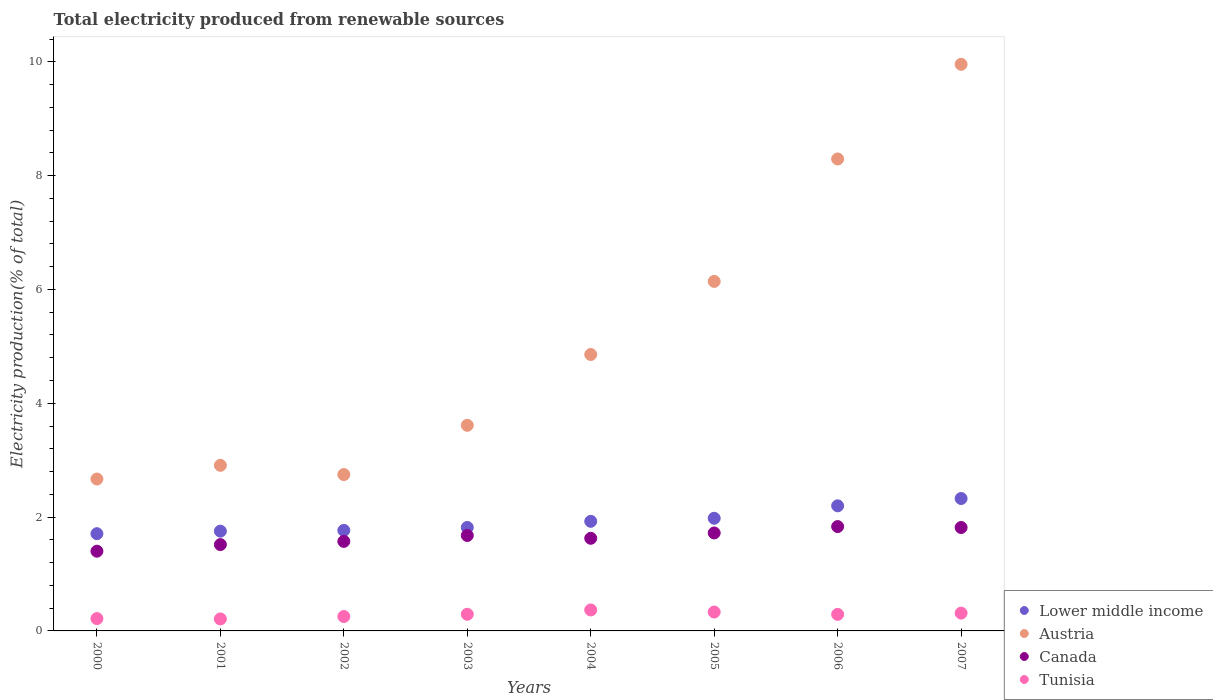How many different coloured dotlines are there?
Your response must be concise. 4. Is the number of dotlines equal to the number of legend labels?
Make the answer very short. Yes. What is the total electricity produced in Lower middle income in 2001?
Offer a terse response. 1.75. Across all years, what is the maximum total electricity produced in Austria?
Keep it short and to the point. 9.96. Across all years, what is the minimum total electricity produced in Canada?
Your answer should be very brief. 1.4. In which year was the total electricity produced in Canada maximum?
Provide a succinct answer. 2006. What is the total total electricity produced in Lower middle income in the graph?
Ensure brevity in your answer.  15.48. What is the difference between the total electricity produced in Lower middle income in 2001 and that in 2007?
Provide a succinct answer. -0.57. What is the difference between the total electricity produced in Tunisia in 2006 and the total electricity produced in Canada in 2001?
Provide a short and direct response. -1.23. What is the average total electricity produced in Austria per year?
Give a very brief answer. 5.15. In the year 2005, what is the difference between the total electricity produced in Austria and total electricity produced in Tunisia?
Keep it short and to the point. 5.81. In how many years, is the total electricity produced in Canada greater than 2 %?
Offer a terse response. 0. What is the ratio of the total electricity produced in Lower middle income in 2004 to that in 2007?
Make the answer very short. 0.83. Is the total electricity produced in Canada in 2001 less than that in 2006?
Keep it short and to the point. Yes. Is the difference between the total electricity produced in Austria in 2001 and 2002 greater than the difference between the total electricity produced in Tunisia in 2001 and 2002?
Your response must be concise. Yes. What is the difference between the highest and the second highest total electricity produced in Lower middle income?
Give a very brief answer. 0.13. What is the difference between the highest and the lowest total electricity produced in Austria?
Offer a very short reply. 7.29. Is the sum of the total electricity produced in Tunisia in 2004 and 2006 greater than the maximum total electricity produced in Lower middle income across all years?
Give a very brief answer. No. Is it the case that in every year, the sum of the total electricity produced in Tunisia and total electricity produced in Canada  is greater than the total electricity produced in Lower middle income?
Keep it short and to the point. No. Is the total electricity produced in Lower middle income strictly greater than the total electricity produced in Canada over the years?
Make the answer very short. Yes. Is the total electricity produced in Tunisia strictly less than the total electricity produced in Lower middle income over the years?
Offer a very short reply. Yes. How many dotlines are there?
Offer a very short reply. 4. What is the difference between two consecutive major ticks on the Y-axis?
Give a very brief answer. 2. Does the graph contain any zero values?
Keep it short and to the point. No. Where does the legend appear in the graph?
Make the answer very short. Bottom right. How many legend labels are there?
Provide a short and direct response. 4. How are the legend labels stacked?
Offer a terse response. Vertical. What is the title of the graph?
Keep it short and to the point. Total electricity produced from renewable sources. Does "Costa Rica" appear as one of the legend labels in the graph?
Your answer should be very brief. No. What is the Electricity production(% of total) of Lower middle income in 2000?
Ensure brevity in your answer.  1.71. What is the Electricity production(% of total) in Austria in 2000?
Provide a succinct answer. 2.67. What is the Electricity production(% of total) in Canada in 2000?
Keep it short and to the point. 1.4. What is the Electricity production(% of total) of Tunisia in 2000?
Offer a very short reply. 0.22. What is the Electricity production(% of total) of Lower middle income in 2001?
Provide a short and direct response. 1.75. What is the Electricity production(% of total) of Austria in 2001?
Offer a terse response. 2.91. What is the Electricity production(% of total) of Canada in 2001?
Make the answer very short. 1.52. What is the Electricity production(% of total) of Tunisia in 2001?
Your response must be concise. 0.21. What is the Electricity production(% of total) in Lower middle income in 2002?
Ensure brevity in your answer.  1.77. What is the Electricity production(% of total) in Austria in 2002?
Offer a very short reply. 2.75. What is the Electricity production(% of total) of Canada in 2002?
Give a very brief answer. 1.57. What is the Electricity production(% of total) of Tunisia in 2002?
Give a very brief answer. 0.25. What is the Electricity production(% of total) in Lower middle income in 2003?
Offer a very short reply. 1.82. What is the Electricity production(% of total) of Austria in 2003?
Your answer should be very brief. 3.61. What is the Electricity production(% of total) in Canada in 2003?
Give a very brief answer. 1.68. What is the Electricity production(% of total) in Tunisia in 2003?
Your response must be concise. 0.29. What is the Electricity production(% of total) in Lower middle income in 2004?
Your response must be concise. 1.93. What is the Electricity production(% of total) in Austria in 2004?
Give a very brief answer. 4.86. What is the Electricity production(% of total) of Canada in 2004?
Ensure brevity in your answer.  1.63. What is the Electricity production(% of total) of Tunisia in 2004?
Ensure brevity in your answer.  0.37. What is the Electricity production(% of total) in Lower middle income in 2005?
Offer a terse response. 1.98. What is the Electricity production(% of total) in Austria in 2005?
Make the answer very short. 6.14. What is the Electricity production(% of total) of Canada in 2005?
Your answer should be compact. 1.72. What is the Electricity production(% of total) of Tunisia in 2005?
Ensure brevity in your answer.  0.33. What is the Electricity production(% of total) in Lower middle income in 2006?
Offer a very short reply. 2.2. What is the Electricity production(% of total) of Austria in 2006?
Ensure brevity in your answer.  8.29. What is the Electricity production(% of total) of Canada in 2006?
Your answer should be compact. 1.83. What is the Electricity production(% of total) of Tunisia in 2006?
Your answer should be compact. 0.29. What is the Electricity production(% of total) of Lower middle income in 2007?
Your response must be concise. 2.33. What is the Electricity production(% of total) in Austria in 2007?
Offer a terse response. 9.96. What is the Electricity production(% of total) of Canada in 2007?
Your answer should be very brief. 1.82. What is the Electricity production(% of total) in Tunisia in 2007?
Give a very brief answer. 0.31. Across all years, what is the maximum Electricity production(% of total) of Lower middle income?
Make the answer very short. 2.33. Across all years, what is the maximum Electricity production(% of total) in Austria?
Provide a short and direct response. 9.96. Across all years, what is the maximum Electricity production(% of total) in Canada?
Ensure brevity in your answer.  1.83. Across all years, what is the maximum Electricity production(% of total) in Tunisia?
Offer a terse response. 0.37. Across all years, what is the minimum Electricity production(% of total) in Lower middle income?
Offer a very short reply. 1.71. Across all years, what is the minimum Electricity production(% of total) of Austria?
Your answer should be very brief. 2.67. Across all years, what is the minimum Electricity production(% of total) of Canada?
Give a very brief answer. 1.4. Across all years, what is the minimum Electricity production(% of total) of Tunisia?
Your answer should be very brief. 0.21. What is the total Electricity production(% of total) of Lower middle income in the graph?
Provide a succinct answer. 15.48. What is the total Electricity production(% of total) in Austria in the graph?
Give a very brief answer. 41.19. What is the total Electricity production(% of total) in Canada in the graph?
Your response must be concise. 13.17. What is the total Electricity production(% of total) of Tunisia in the graph?
Give a very brief answer. 2.28. What is the difference between the Electricity production(% of total) in Lower middle income in 2000 and that in 2001?
Your answer should be very brief. -0.04. What is the difference between the Electricity production(% of total) of Austria in 2000 and that in 2001?
Give a very brief answer. -0.24. What is the difference between the Electricity production(% of total) in Canada in 2000 and that in 2001?
Offer a terse response. -0.12. What is the difference between the Electricity production(% of total) in Tunisia in 2000 and that in 2001?
Your answer should be compact. 0.01. What is the difference between the Electricity production(% of total) in Lower middle income in 2000 and that in 2002?
Your answer should be compact. -0.06. What is the difference between the Electricity production(% of total) of Austria in 2000 and that in 2002?
Offer a terse response. -0.08. What is the difference between the Electricity production(% of total) of Canada in 2000 and that in 2002?
Provide a short and direct response. -0.17. What is the difference between the Electricity production(% of total) of Tunisia in 2000 and that in 2002?
Make the answer very short. -0.04. What is the difference between the Electricity production(% of total) in Lower middle income in 2000 and that in 2003?
Ensure brevity in your answer.  -0.11. What is the difference between the Electricity production(% of total) in Austria in 2000 and that in 2003?
Give a very brief answer. -0.94. What is the difference between the Electricity production(% of total) in Canada in 2000 and that in 2003?
Your answer should be compact. -0.28. What is the difference between the Electricity production(% of total) in Tunisia in 2000 and that in 2003?
Your answer should be very brief. -0.08. What is the difference between the Electricity production(% of total) in Lower middle income in 2000 and that in 2004?
Ensure brevity in your answer.  -0.22. What is the difference between the Electricity production(% of total) of Austria in 2000 and that in 2004?
Your response must be concise. -2.19. What is the difference between the Electricity production(% of total) of Canada in 2000 and that in 2004?
Provide a succinct answer. -0.23. What is the difference between the Electricity production(% of total) of Tunisia in 2000 and that in 2004?
Make the answer very short. -0.15. What is the difference between the Electricity production(% of total) of Lower middle income in 2000 and that in 2005?
Your answer should be very brief. -0.27. What is the difference between the Electricity production(% of total) in Austria in 2000 and that in 2005?
Offer a very short reply. -3.47. What is the difference between the Electricity production(% of total) in Canada in 2000 and that in 2005?
Offer a very short reply. -0.32. What is the difference between the Electricity production(% of total) in Tunisia in 2000 and that in 2005?
Offer a terse response. -0.11. What is the difference between the Electricity production(% of total) in Lower middle income in 2000 and that in 2006?
Provide a succinct answer. -0.49. What is the difference between the Electricity production(% of total) of Austria in 2000 and that in 2006?
Give a very brief answer. -5.62. What is the difference between the Electricity production(% of total) of Canada in 2000 and that in 2006?
Give a very brief answer. -0.43. What is the difference between the Electricity production(% of total) of Tunisia in 2000 and that in 2006?
Offer a very short reply. -0.07. What is the difference between the Electricity production(% of total) in Lower middle income in 2000 and that in 2007?
Give a very brief answer. -0.62. What is the difference between the Electricity production(% of total) in Austria in 2000 and that in 2007?
Your response must be concise. -7.29. What is the difference between the Electricity production(% of total) in Canada in 2000 and that in 2007?
Provide a succinct answer. -0.42. What is the difference between the Electricity production(% of total) of Tunisia in 2000 and that in 2007?
Provide a short and direct response. -0.1. What is the difference between the Electricity production(% of total) of Lower middle income in 2001 and that in 2002?
Your answer should be very brief. -0.01. What is the difference between the Electricity production(% of total) in Austria in 2001 and that in 2002?
Offer a very short reply. 0.16. What is the difference between the Electricity production(% of total) of Canada in 2001 and that in 2002?
Provide a short and direct response. -0.06. What is the difference between the Electricity production(% of total) in Tunisia in 2001 and that in 2002?
Provide a succinct answer. -0.04. What is the difference between the Electricity production(% of total) of Lower middle income in 2001 and that in 2003?
Your response must be concise. -0.07. What is the difference between the Electricity production(% of total) of Austria in 2001 and that in 2003?
Your answer should be compact. -0.7. What is the difference between the Electricity production(% of total) in Canada in 2001 and that in 2003?
Make the answer very short. -0.16. What is the difference between the Electricity production(% of total) of Tunisia in 2001 and that in 2003?
Give a very brief answer. -0.08. What is the difference between the Electricity production(% of total) of Lower middle income in 2001 and that in 2004?
Give a very brief answer. -0.17. What is the difference between the Electricity production(% of total) of Austria in 2001 and that in 2004?
Your response must be concise. -1.95. What is the difference between the Electricity production(% of total) in Canada in 2001 and that in 2004?
Give a very brief answer. -0.11. What is the difference between the Electricity production(% of total) of Tunisia in 2001 and that in 2004?
Offer a terse response. -0.16. What is the difference between the Electricity production(% of total) of Lower middle income in 2001 and that in 2005?
Offer a terse response. -0.23. What is the difference between the Electricity production(% of total) of Austria in 2001 and that in 2005?
Give a very brief answer. -3.23. What is the difference between the Electricity production(% of total) in Canada in 2001 and that in 2005?
Keep it short and to the point. -0.2. What is the difference between the Electricity production(% of total) of Tunisia in 2001 and that in 2005?
Provide a succinct answer. -0.12. What is the difference between the Electricity production(% of total) of Lower middle income in 2001 and that in 2006?
Offer a very short reply. -0.45. What is the difference between the Electricity production(% of total) in Austria in 2001 and that in 2006?
Your answer should be very brief. -5.38. What is the difference between the Electricity production(% of total) in Canada in 2001 and that in 2006?
Keep it short and to the point. -0.32. What is the difference between the Electricity production(% of total) of Tunisia in 2001 and that in 2006?
Provide a short and direct response. -0.08. What is the difference between the Electricity production(% of total) in Lower middle income in 2001 and that in 2007?
Make the answer very short. -0.57. What is the difference between the Electricity production(% of total) of Austria in 2001 and that in 2007?
Offer a very short reply. -7.05. What is the difference between the Electricity production(% of total) in Canada in 2001 and that in 2007?
Your answer should be compact. -0.3. What is the difference between the Electricity production(% of total) of Tunisia in 2001 and that in 2007?
Give a very brief answer. -0.1. What is the difference between the Electricity production(% of total) of Lower middle income in 2002 and that in 2003?
Your answer should be compact. -0.05. What is the difference between the Electricity production(% of total) of Austria in 2002 and that in 2003?
Give a very brief answer. -0.87. What is the difference between the Electricity production(% of total) in Canada in 2002 and that in 2003?
Make the answer very short. -0.1. What is the difference between the Electricity production(% of total) in Tunisia in 2002 and that in 2003?
Ensure brevity in your answer.  -0.04. What is the difference between the Electricity production(% of total) of Lower middle income in 2002 and that in 2004?
Make the answer very short. -0.16. What is the difference between the Electricity production(% of total) of Austria in 2002 and that in 2004?
Offer a terse response. -2.11. What is the difference between the Electricity production(% of total) of Canada in 2002 and that in 2004?
Provide a succinct answer. -0.05. What is the difference between the Electricity production(% of total) in Tunisia in 2002 and that in 2004?
Ensure brevity in your answer.  -0.12. What is the difference between the Electricity production(% of total) in Lower middle income in 2002 and that in 2005?
Provide a short and direct response. -0.21. What is the difference between the Electricity production(% of total) in Austria in 2002 and that in 2005?
Keep it short and to the point. -3.39. What is the difference between the Electricity production(% of total) of Canada in 2002 and that in 2005?
Give a very brief answer. -0.15. What is the difference between the Electricity production(% of total) of Tunisia in 2002 and that in 2005?
Ensure brevity in your answer.  -0.08. What is the difference between the Electricity production(% of total) of Lower middle income in 2002 and that in 2006?
Your answer should be compact. -0.43. What is the difference between the Electricity production(% of total) in Austria in 2002 and that in 2006?
Offer a terse response. -5.55. What is the difference between the Electricity production(% of total) of Canada in 2002 and that in 2006?
Make the answer very short. -0.26. What is the difference between the Electricity production(% of total) of Tunisia in 2002 and that in 2006?
Provide a short and direct response. -0.04. What is the difference between the Electricity production(% of total) in Lower middle income in 2002 and that in 2007?
Your response must be concise. -0.56. What is the difference between the Electricity production(% of total) of Austria in 2002 and that in 2007?
Your answer should be compact. -7.21. What is the difference between the Electricity production(% of total) of Canada in 2002 and that in 2007?
Keep it short and to the point. -0.24. What is the difference between the Electricity production(% of total) in Tunisia in 2002 and that in 2007?
Keep it short and to the point. -0.06. What is the difference between the Electricity production(% of total) of Lower middle income in 2003 and that in 2004?
Provide a short and direct response. -0.11. What is the difference between the Electricity production(% of total) in Austria in 2003 and that in 2004?
Your answer should be compact. -1.24. What is the difference between the Electricity production(% of total) in Canada in 2003 and that in 2004?
Provide a short and direct response. 0.05. What is the difference between the Electricity production(% of total) in Tunisia in 2003 and that in 2004?
Make the answer very short. -0.08. What is the difference between the Electricity production(% of total) in Lower middle income in 2003 and that in 2005?
Make the answer very short. -0.16. What is the difference between the Electricity production(% of total) of Austria in 2003 and that in 2005?
Make the answer very short. -2.53. What is the difference between the Electricity production(% of total) of Canada in 2003 and that in 2005?
Provide a succinct answer. -0.04. What is the difference between the Electricity production(% of total) in Tunisia in 2003 and that in 2005?
Your answer should be very brief. -0.04. What is the difference between the Electricity production(% of total) in Lower middle income in 2003 and that in 2006?
Provide a succinct answer. -0.38. What is the difference between the Electricity production(% of total) of Austria in 2003 and that in 2006?
Ensure brevity in your answer.  -4.68. What is the difference between the Electricity production(% of total) in Canada in 2003 and that in 2006?
Provide a short and direct response. -0.16. What is the difference between the Electricity production(% of total) in Tunisia in 2003 and that in 2006?
Provide a succinct answer. 0. What is the difference between the Electricity production(% of total) of Lower middle income in 2003 and that in 2007?
Provide a succinct answer. -0.51. What is the difference between the Electricity production(% of total) in Austria in 2003 and that in 2007?
Provide a succinct answer. -6.34. What is the difference between the Electricity production(% of total) of Canada in 2003 and that in 2007?
Make the answer very short. -0.14. What is the difference between the Electricity production(% of total) of Tunisia in 2003 and that in 2007?
Make the answer very short. -0.02. What is the difference between the Electricity production(% of total) in Lower middle income in 2004 and that in 2005?
Ensure brevity in your answer.  -0.05. What is the difference between the Electricity production(% of total) in Austria in 2004 and that in 2005?
Give a very brief answer. -1.28. What is the difference between the Electricity production(% of total) of Canada in 2004 and that in 2005?
Give a very brief answer. -0.09. What is the difference between the Electricity production(% of total) in Tunisia in 2004 and that in 2005?
Provide a succinct answer. 0.04. What is the difference between the Electricity production(% of total) in Lower middle income in 2004 and that in 2006?
Ensure brevity in your answer.  -0.27. What is the difference between the Electricity production(% of total) in Austria in 2004 and that in 2006?
Your response must be concise. -3.44. What is the difference between the Electricity production(% of total) of Canada in 2004 and that in 2006?
Provide a short and direct response. -0.21. What is the difference between the Electricity production(% of total) of Tunisia in 2004 and that in 2006?
Give a very brief answer. 0.08. What is the difference between the Electricity production(% of total) of Lower middle income in 2004 and that in 2007?
Provide a succinct answer. -0.4. What is the difference between the Electricity production(% of total) of Austria in 2004 and that in 2007?
Make the answer very short. -5.1. What is the difference between the Electricity production(% of total) of Canada in 2004 and that in 2007?
Your response must be concise. -0.19. What is the difference between the Electricity production(% of total) in Tunisia in 2004 and that in 2007?
Provide a succinct answer. 0.06. What is the difference between the Electricity production(% of total) of Lower middle income in 2005 and that in 2006?
Keep it short and to the point. -0.22. What is the difference between the Electricity production(% of total) in Austria in 2005 and that in 2006?
Give a very brief answer. -2.15. What is the difference between the Electricity production(% of total) in Canada in 2005 and that in 2006?
Give a very brief answer. -0.11. What is the difference between the Electricity production(% of total) in Tunisia in 2005 and that in 2006?
Your response must be concise. 0.04. What is the difference between the Electricity production(% of total) of Lower middle income in 2005 and that in 2007?
Make the answer very short. -0.35. What is the difference between the Electricity production(% of total) in Austria in 2005 and that in 2007?
Keep it short and to the point. -3.81. What is the difference between the Electricity production(% of total) of Canada in 2005 and that in 2007?
Make the answer very short. -0.1. What is the difference between the Electricity production(% of total) in Tunisia in 2005 and that in 2007?
Keep it short and to the point. 0.02. What is the difference between the Electricity production(% of total) in Lower middle income in 2006 and that in 2007?
Offer a very short reply. -0.13. What is the difference between the Electricity production(% of total) in Austria in 2006 and that in 2007?
Keep it short and to the point. -1.66. What is the difference between the Electricity production(% of total) of Canada in 2006 and that in 2007?
Offer a very short reply. 0.02. What is the difference between the Electricity production(% of total) in Tunisia in 2006 and that in 2007?
Your answer should be compact. -0.02. What is the difference between the Electricity production(% of total) of Lower middle income in 2000 and the Electricity production(% of total) of Austria in 2001?
Your answer should be very brief. -1.2. What is the difference between the Electricity production(% of total) of Lower middle income in 2000 and the Electricity production(% of total) of Canada in 2001?
Provide a succinct answer. 0.19. What is the difference between the Electricity production(% of total) of Lower middle income in 2000 and the Electricity production(% of total) of Tunisia in 2001?
Make the answer very short. 1.5. What is the difference between the Electricity production(% of total) in Austria in 2000 and the Electricity production(% of total) in Canada in 2001?
Make the answer very short. 1.15. What is the difference between the Electricity production(% of total) of Austria in 2000 and the Electricity production(% of total) of Tunisia in 2001?
Provide a succinct answer. 2.46. What is the difference between the Electricity production(% of total) of Canada in 2000 and the Electricity production(% of total) of Tunisia in 2001?
Offer a terse response. 1.19. What is the difference between the Electricity production(% of total) in Lower middle income in 2000 and the Electricity production(% of total) in Austria in 2002?
Your response must be concise. -1.04. What is the difference between the Electricity production(% of total) in Lower middle income in 2000 and the Electricity production(% of total) in Canada in 2002?
Your answer should be compact. 0.14. What is the difference between the Electricity production(% of total) in Lower middle income in 2000 and the Electricity production(% of total) in Tunisia in 2002?
Make the answer very short. 1.46. What is the difference between the Electricity production(% of total) of Austria in 2000 and the Electricity production(% of total) of Canada in 2002?
Provide a short and direct response. 1.1. What is the difference between the Electricity production(% of total) of Austria in 2000 and the Electricity production(% of total) of Tunisia in 2002?
Your answer should be compact. 2.42. What is the difference between the Electricity production(% of total) of Canada in 2000 and the Electricity production(% of total) of Tunisia in 2002?
Your answer should be compact. 1.15. What is the difference between the Electricity production(% of total) of Lower middle income in 2000 and the Electricity production(% of total) of Austria in 2003?
Your answer should be very brief. -1.9. What is the difference between the Electricity production(% of total) of Lower middle income in 2000 and the Electricity production(% of total) of Canada in 2003?
Offer a very short reply. 0.03. What is the difference between the Electricity production(% of total) of Lower middle income in 2000 and the Electricity production(% of total) of Tunisia in 2003?
Ensure brevity in your answer.  1.42. What is the difference between the Electricity production(% of total) in Austria in 2000 and the Electricity production(% of total) in Canada in 2003?
Ensure brevity in your answer.  0.99. What is the difference between the Electricity production(% of total) of Austria in 2000 and the Electricity production(% of total) of Tunisia in 2003?
Your response must be concise. 2.38. What is the difference between the Electricity production(% of total) of Canada in 2000 and the Electricity production(% of total) of Tunisia in 2003?
Offer a very short reply. 1.11. What is the difference between the Electricity production(% of total) in Lower middle income in 2000 and the Electricity production(% of total) in Austria in 2004?
Keep it short and to the point. -3.15. What is the difference between the Electricity production(% of total) of Lower middle income in 2000 and the Electricity production(% of total) of Canada in 2004?
Your answer should be compact. 0.08. What is the difference between the Electricity production(% of total) of Lower middle income in 2000 and the Electricity production(% of total) of Tunisia in 2004?
Your response must be concise. 1.34. What is the difference between the Electricity production(% of total) in Austria in 2000 and the Electricity production(% of total) in Canada in 2004?
Ensure brevity in your answer.  1.04. What is the difference between the Electricity production(% of total) of Austria in 2000 and the Electricity production(% of total) of Tunisia in 2004?
Give a very brief answer. 2.3. What is the difference between the Electricity production(% of total) in Canada in 2000 and the Electricity production(% of total) in Tunisia in 2004?
Your response must be concise. 1.03. What is the difference between the Electricity production(% of total) of Lower middle income in 2000 and the Electricity production(% of total) of Austria in 2005?
Make the answer very short. -4.43. What is the difference between the Electricity production(% of total) in Lower middle income in 2000 and the Electricity production(% of total) in Canada in 2005?
Offer a terse response. -0.01. What is the difference between the Electricity production(% of total) in Lower middle income in 2000 and the Electricity production(% of total) in Tunisia in 2005?
Ensure brevity in your answer.  1.38. What is the difference between the Electricity production(% of total) in Austria in 2000 and the Electricity production(% of total) in Canada in 2005?
Make the answer very short. 0.95. What is the difference between the Electricity production(% of total) in Austria in 2000 and the Electricity production(% of total) in Tunisia in 2005?
Provide a succinct answer. 2.34. What is the difference between the Electricity production(% of total) in Canada in 2000 and the Electricity production(% of total) in Tunisia in 2005?
Make the answer very short. 1.07. What is the difference between the Electricity production(% of total) of Lower middle income in 2000 and the Electricity production(% of total) of Austria in 2006?
Your answer should be compact. -6.58. What is the difference between the Electricity production(% of total) in Lower middle income in 2000 and the Electricity production(% of total) in Canada in 2006?
Provide a short and direct response. -0.13. What is the difference between the Electricity production(% of total) in Lower middle income in 2000 and the Electricity production(% of total) in Tunisia in 2006?
Offer a terse response. 1.42. What is the difference between the Electricity production(% of total) of Austria in 2000 and the Electricity production(% of total) of Canada in 2006?
Your answer should be very brief. 0.84. What is the difference between the Electricity production(% of total) in Austria in 2000 and the Electricity production(% of total) in Tunisia in 2006?
Ensure brevity in your answer.  2.38. What is the difference between the Electricity production(% of total) in Canada in 2000 and the Electricity production(% of total) in Tunisia in 2006?
Your answer should be very brief. 1.11. What is the difference between the Electricity production(% of total) in Lower middle income in 2000 and the Electricity production(% of total) in Austria in 2007?
Keep it short and to the point. -8.25. What is the difference between the Electricity production(% of total) in Lower middle income in 2000 and the Electricity production(% of total) in Canada in 2007?
Give a very brief answer. -0.11. What is the difference between the Electricity production(% of total) in Lower middle income in 2000 and the Electricity production(% of total) in Tunisia in 2007?
Give a very brief answer. 1.4. What is the difference between the Electricity production(% of total) in Austria in 2000 and the Electricity production(% of total) in Canada in 2007?
Offer a very short reply. 0.85. What is the difference between the Electricity production(% of total) in Austria in 2000 and the Electricity production(% of total) in Tunisia in 2007?
Keep it short and to the point. 2.36. What is the difference between the Electricity production(% of total) in Canada in 2000 and the Electricity production(% of total) in Tunisia in 2007?
Provide a short and direct response. 1.09. What is the difference between the Electricity production(% of total) of Lower middle income in 2001 and the Electricity production(% of total) of Austria in 2002?
Provide a succinct answer. -0.99. What is the difference between the Electricity production(% of total) in Lower middle income in 2001 and the Electricity production(% of total) in Canada in 2002?
Ensure brevity in your answer.  0.18. What is the difference between the Electricity production(% of total) of Lower middle income in 2001 and the Electricity production(% of total) of Tunisia in 2002?
Your answer should be very brief. 1.5. What is the difference between the Electricity production(% of total) in Austria in 2001 and the Electricity production(% of total) in Canada in 2002?
Your answer should be compact. 1.34. What is the difference between the Electricity production(% of total) in Austria in 2001 and the Electricity production(% of total) in Tunisia in 2002?
Keep it short and to the point. 2.66. What is the difference between the Electricity production(% of total) of Canada in 2001 and the Electricity production(% of total) of Tunisia in 2002?
Provide a succinct answer. 1.26. What is the difference between the Electricity production(% of total) in Lower middle income in 2001 and the Electricity production(% of total) in Austria in 2003?
Your response must be concise. -1.86. What is the difference between the Electricity production(% of total) in Lower middle income in 2001 and the Electricity production(% of total) in Canada in 2003?
Provide a short and direct response. 0.08. What is the difference between the Electricity production(% of total) of Lower middle income in 2001 and the Electricity production(% of total) of Tunisia in 2003?
Provide a short and direct response. 1.46. What is the difference between the Electricity production(% of total) of Austria in 2001 and the Electricity production(% of total) of Canada in 2003?
Provide a succinct answer. 1.23. What is the difference between the Electricity production(% of total) of Austria in 2001 and the Electricity production(% of total) of Tunisia in 2003?
Keep it short and to the point. 2.62. What is the difference between the Electricity production(% of total) of Canada in 2001 and the Electricity production(% of total) of Tunisia in 2003?
Provide a succinct answer. 1.22. What is the difference between the Electricity production(% of total) in Lower middle income in 2001 and the Electricity production(% of total) in Austria in 2004?
Offer a terse response. -3.1. What is the difference between the Electricity production(% of total) of Lower middle income in 2001 and the Electricity production(% of total) of Canada in 2004?
Make the answer very short. 0.13. What is the difference between the Electricity production(% of total) of Lower middle income in 2001 and the Electricity production(% of total) of Tunisia in 2004?
Offer a terse response. 1.38. What is the difference between the Electricity production(% of total) of Austria in 2001 and the Electricity production(% of total) of Canada in 2004?
Offer a terse response. 1.28. What is the difference between the Electricity production(% of total) in Austria in 2001 and the Electricity production(% of total) in Tunisia in 2004?
Make the answer very short. 2.54. What is the difference between the Electricity production(% of total) of Canada in 2001 and the Electricity production(% of total) of Tunisia in 2004?
Your response must be concise. 1.15. What is the difference between the Electricity production(% of total) in Lower middle income in 2001 and the Electricity production(% of total) in Austria in 2005?
Ensure brevity in your answer.  -4.39. What is the difference between the Electricity production(% of total) in Lower middle income in 2001 and the Electricity production(% of total) in Canada in 2005?
Provide a succinct answer. 0.03. What is the difference between the Electricity production(% of total) in Lower middle income in 2001 and the Electricity production(% of total) in Tunisia in 2005?
Offer a very short reply. 1.42. What is the difference between the Electricity production(% of total) in Austria in 2001 and the Electricity production(% of total) in Canada in 2005?
Provide a succinct answer. 1.19. What is the difference between the Electricity production(% of total) in Austria in 2001 and the Electricity production(% of total) in Tunisia in 2005?
Ensure brevity in your answer.  2.58. What is the difference between the Electricity production(% of total) of Canada in 2001 and the Electricity production(% of total) of Tunisia in 2005?
Provide a short and direct response. 1.19. What is the difference between the Electricity production(% of total) of Lower middle income in 2001 and the Electricity production(% of total) of Austria in 2006?
Provide a short and direct response. -6.54. What is the difference between the Electricity production(% of total) of Lower middle income in 2001 and the Electricity production(% of total) of Canada in 2006?
Offer a very short reply. -0.08. What is the difference between the Electricity production(% of total) of Lower middle income in 2001 and the Electricity production(% of total) of Tunisia in 2006?
Give a very brief answer. 1.46. What is the difference between the Electricity production(% of total) of Austria in 2001 and the Electricity production(% of total) of Canada in 2006?
Provide a succinct answer. 1.08. What is the difference between the Electricity production(% of total) of Austria in 2001 and the Electricity production(% of total) of Tunisia in 2006?
Give a very brief answer. 2.62. What is the difference between the Electricity production(% of total) of Canada in 2001 and the Electricity production(% of total) of Tunisia in 2006?
Your answer should be very brief. 1.23. What is the difference between the Electricity production(% of total) in Lower middle income in 2001 and the Electricity production(% of total) in Austria in 2007?
Ensure brevity in your answer.  -8.2. What is the difference between the Electricity production(% of total) of Lower middle income in 2001 and the Electricity production(% of total) of Canada in 2007?
Your answer should be compact. -0.06. What is the difference between the Electricity production(% of total) in Lower middle income in 2001 and the Electricity production(% of total) in Tunisia in 2007?
Your answer should be compact. 1.44. What is the difference between the Electricity production(% of total) of Austria in 2001 and the Electricity production(% of total) of Canada in 2007?
Your answer should be very brief. 1.09. What is the difference between the Electricity production(% of total) of Austria in 2001 and the Electricity production(% of total) of Tunisia in 2007?
Provide a succinct answer. 2.6. What is the difference between the Electricity production(% of total) in Canada in 2001 and the Electricity production(% of total) in Tunisia in 2007?
Offer a very short reply. 1.2. What is the difference between the Electricity production(% of total) of Lower middle income in 2002 and the Electricity production(% of total) of Austria in 2003?
Give a very brief answer. -1.85. What is the difference between the Electricity production(% of total) in Lower middle income in 2002 and the Electricity production(% of total) in Canada in 2003?
Give a very brief answer. 0.09. What is the difference between the Electricity production(% of total) of Lower middle income in 2002 and the Electricity production(% of total) of Tunisia in 2003?
Offer a terse response. 1.47. What is the difference between the Electricity production(% of total) in Austria in 2002 and the Electricity production(% of total) in Canada in 2003?
Keep it short and to the point. 1.07. What is the difference between the Electricity production(% of total) in Austria in 2002 and the Electricity production(% of total) in Tunisia in 2003?
Offer a terse response. 2.46. What is the difference between the Electricity production(% of total) of Canada in 2002 and the Electricity production(% of total) of Tunisia in 2003?
Offer a terse response. 1.28. What is the difference between the Electricity production(% of total) in Lower middle income in 2002 and the Electricity production(% of total) in Austria in 2004?
Your response must be concise. -3.09. What is the difference between the Electricity production(% of total) in Lower middle income in 2002 and the Electricity production(% of total) in Canada in 2004?
Your answer should be very brief. 0.14. What is the difference between the Electricity production(% of total) in Lower middle income in 2002 and the Electricity production(% of total) in Tunisia in 2004?
Your answer should be compact. 1.4. What is the difference between the Electricity production(% of total) of Austria in 2002 and the Electricity production(% of total) of Canada in 2004?
Offer a terse response. 1.12. What is the difference between the Electricity production(% of total) in Austria in 2002 and the Electricity production(% of total) in Tunisia in 2004?
Give a very brief answer. 2.38. What is the difference between the Electricity production(% of total) in Canada in 2002 and the Electricity production(% of total) in Tunisia in 2004?
Ensure brevity in your answer.  1.2. What is the difference between the Electricity production(% of total) in Lower middle income in 2002 and the Electricity production(% of total) in Austria in 2005?
Your answer should be very brief. -4.38. What is the difference between the Electricity production(% of total) of Lower middle income in 2002 and the Electricity production(% of total) of Canada in 2005?
Offer a very short reply. 0.04. What is the difference between the Electricity production(% of total) in Lower middle income in 2002 and the Electricity production(% of total) in Tunisia in 2005?
Offer a terse response. 1.43. What is the difference between the Electricity production(% of total) of Austria in 2002 and the Electricity production(% of total) of Canada in 2005?
Provide a succinct answer. 1.03. What is the difference between the Electricity production(% of total) in Austria in 2002 and the Electricity production(% of total) in Tunisia in 2005?
Provide a succinct answer. 2.42. What is the difference between the Electricity production(% of total) in Canada in 2002 and the Electricity production(% of total) in Tunisia in 2005?
Offer a very short reply. 1.24. What is the difference between the Electricity production(% of total) in Lower middle income in 2002 and the Electricity production(% of total) in Austria in 2006?
Ensure brevity in your answer.  -6.53. What is the difference between the Electricity production(% of total) of Lower middle income in 2002 and the Electricity production(% of total) of Canada in 2006?
Keep it short and to the point. -0.07. What is the difference between the Electricity production(% of total) in Lower middle income in 2002 and the Electricity production(% of total) in Tunisia in 2006?
Provide a short and direct response. 1.48. What is the difference between the Electricity production(% of total) in Austria in 2002 and the Electricity production(% of total) in Canada in 2006?
Your answer should be compact. 0.91. What is the difference between the Electricity production(% of total) in Austria in 2002 and the Electricity production(% of total) in Tunisia in 2006?
Make the answer very short. 2.46. What is the difference between the Electricity production(% of total) of Canada in 2002 and the Electricity production(% of total) of Tunisia in 2006?
Ensure brevity in your answer.  1.28. What is the difference between the Electricity production(% of total) of Lower middle income in 2002 and the Electricity production(% of total) of Austria in 2007?
Offer a very short reply. -8.19. What is the difference between the Electricity production(% of total) in Lower middle income in 2002 and the Electricity production(% of total) in Canada in 2007?
Your response must be concise. -0.05. What is the difference between the Electricity production(% of total) in Lower middle income in 2002 and the Electricity production(% of total) in Tunisia in 2007?
Your answer should be very brief. 1.45. What is the difference between the Electricity production(% of total) in Austria in 2002 and the Electricity production(% of total) in Canada in 2007?
Offer a very short reply. 0.93. What is the difference between the Electricity production(% of total) of Austria in 2002 and the Electricity production(% of total) of Tunisia in 2007?
Ensure brevity in your answer.  2.43. What is the difference between the Electricity production(% of total) in Canada in 2002 and the Electricity production(% of total) in Tunisia in 2007?
Ensure brevity in your answer.  1.26. What is the difference between the Electricity production(% of total) of Lower middle income in 2003 and the Electricity production(% of total) of Austria in 2004?
Offer a very short reply. -3.04. What is the difference between the Electricity production(% of total) in Lower middle income in 2003 and the Electricity production(% of total) in Canada in 2004?
Your answer should be very brief. 0.19. What is the difference between the Electricity production(% of total) of Lower middle income in 2003 and the Electricity production(% of total) of Tunisia in 2004?
Keep it short and to the point. 1.45. What is the difference between the Electricity production(% of total) in Austria in 2003 and the Electricity production(% of total) in Canada in 2004?
Your response must be concise. 1.99. What is the difference between the Electricity production(% of total) in Austria in 2003 and the Electricity production(% of total) in Tunisia in 2004?
Your answer should be very brief. 3.24. What is the difference between the Electricity production(% of total) of Canada in 2003 and the Electricity production(% of total) of Tunisia in 2004?
Offer a terse response. 1.31. What is the difference between the Electricity production(% of total) in Lower middle income in 2003 and the Electricity production(% of total) in Austria in 2005?
Offer a terse response. -4.32. What is the difference between the Electricity production(% of total) of Lower middle income in 2003 and the Electricity production(% of total) of Canada in 2005?
Your answer should be very brief. 0.1. What is the difference between the Electricity production(% of total) of Lower middle income in 2003 and the Electricity production(% of total) of Tunisia in 2005?
Your answer should be compact. 1.49. What is the difference between the Electricity production(% of total) in Austria in 2003 and the Electricity production(% of total) in Canada in 2005?
Ensure brevity in your answer.  1.89. What is the difference between the Electricity production(% of total) of Austria in 2003 and the Electricity production(% of total) of Tunisia in 2005?
Provide a succinct answer. 3.28. What is the difference between the Electricity production(% of total) of Canada in 2003 and the Electricity production(% of total) of Tunisia in 2005?
Offer a very short reply. 1.35. What is the difference between the Electricity production(% of total) in Lower middle income in 2003 and the Electricity production(% of total) in Austria in 2006?
Keep it short and to the point. -6.47. What is the difference between the Electricity production(% of total) of Lower middle income in 2003 and the Electricity production(% of total) of Canada in 2006?
Offer a terse response. -0.02. What is the difference between the Electricity production(% of total) of Lower middle income in 2003 and the Electricity production(% of total) of Tunisia in 2006?
Your answer should be compact. 1.53. What is the difference between the Electricity production(% of total) of Austria in 2003 and the Electricity production(% of total) of Canada in 2006?
Your answer should be compact. 1.78. What is the difference between the Electricity production(% of total) of Austria in 2003 and the Electricity production(% of total) of Tunisia in 2006?
Keep it short and to the point. 3.32. What is the difference between the Electricity production(% of total) of Canada in 2003 and the Electricity production(% of total) of Tunisia in 2006?
Offer a terse response. 1.39. What is the difference between the Electricity production(% of total) of Lower middle income in 2003 and the Electricity production(% of total) of Austria in 2007?
Your response must be concise. -8.14. What is the difference between the Electricity production(% of total) in Lower middle income in 2003 and the Electricity production(% of total) in Tunisia in 2007?
Make the answer very short. 1.51. What is the difference between the Electricity production(% of total) of Austria in 2003 and the Electricity production(% of total) of Canada in 2007?
Provide a succinct answer. 1.8. What is the difference between the Electricity production(% of total) of Austria in 2003 and the Electricity production(% of total) of Tunisia in 2007?
Your answer should be very brief. 3.3. What is the difference between the Electricity production(% of total) of Canada in 2003 and the Electricity production(% of total) of Tunisia in 2007?
Offer a terse response. 1.36. What is the difference between the Electricity production(% of total) of Lower middle income in 2004 and the Electricity production(% of total) of Austria in 2005?
Your response must be concise. -4.22. What is the difference between the Electricity production(% of total) of Lower middle income in 2004 and the Electricity production(% of total) of Canada in 2005?
Provide a succinct answer. 0.2. What is the difference between the Electricity production(% of total) of Lower middle income in 2004 and the Electricity production(% of total) of Tunisia in 2005?
Give a very brief answer. 1.59. What is the difference between the Electricity production(% of total) of Austria in 2004 and the Electricity production(% of total) of Canada in 2005?
Keep it short and to the point. 3.14. What is the difference between the Electricity production(% of total) in Austria in 2004 and the Electricity production(% of total) in Tunisia in 2005?
Provide a short and direct response. 4.53. What is the difference between the Electricity production(% of total) of Canada in 2004 and the Electricity production(% of total) of Tunisia in 2005?
Your response must be concise. 1.3. What is the difference between the Electricity production(% of total) of Lower middle income in 2004 and the Electricity production(% of total) of Austria in 2006?
Make the answer very short. -6.37. What is the difference between the Electricity production(% of total) in Lower middle income in 2004 and the Electricity production(% of total) in Canada in 2006?
Provide a short and direct response. 0.09. What is the difference between the Electricity production(% of total) of Lower middle income in 2004 and the Electricity production(% of total) of Tunisia in 2006?
Your answer should be compact. 1.63. What is the difference between the Electricity production(% of total) of Austria in 2004 and the Electricity production(% of total) of Canada in 2006?
Make the answer very short. 3.02. What is the difference between the Electricity production(% of total) in Austria in 2004 and the Electricity production(% of total) in Tunisia in 2006?
Offer a terse response. 4.57. What is the difference between the Electricity production(% of total) of Canada in 2004 and the Electricity production(% of total) of Tunisia in 2006?
Make the answer very short. 1.34. What is the difference between the Electricity production(% of total) in Lower middle income in 2004 and the Electricity production(% of total) in Austria in 2007?
Your response must be concise. -8.03. What is the difference between the Electricity production(% of total) in Lower middle income in 2004 and the Electricity production(% of total) in Canada in 2007?
Make the answer very short. 0.11. What is the difference between the Electricity production(% of total) of Lower middle income in 2004 and the Electricity production(% of total) of Tunisia in 2007?
Ensure brevity in your answer.  1.61. What is the difference between the Electricity production(% of total) in Austria in 2004 and the Electricity production(% of total) in Canada in 2007?
Your response must be concise. 3.04. What is the difference between the Electricity production(% of total) of Austria in 2004 and the Electricity production(% of total) of Tunisia in 2007?
Your answer should be compact. 4.54. What is the difference between the Electricity production(% of total) of Canada in 2004 and the Electricity production(% of total) of Tunisia in 2007?
Offer a very short reply. 1.31. What is the difference between the Electricity production(% of total) of Lower middle income in 2005 and the Electricity production(% of total) of Austria in 2006?
Give a very brief answer. -6.31. What is the difference between the Electricity production(% of total) in Lower middle income in 2005 and the Electricity production(% of total) in Canada in 2006?
Keep it short and to the point. 0.15. What is the difference between the Electricity production(% of total) in Lower middle income in 2005 and the Electricity production(% of total) in Tunisia in 2006?
Make the answer very short. 1.69. What is the difference between the Electricity production(% of total) of Austria in 2005 and the Electricity production(% of total) of Canada in 2006?
Your answer should be very brief. 4.31. What is the difference between the Electricity production(% of total) in Austria in 2005 and the Electricity production(% of total) in Tunisia in 2006?
Provide a succinct answer. 5.85. What is the difference between the Electricity production(% of total) in Canada in 2005 and the Electricity production(% of total) in Tunisia in 2006?
Make the answer very short. 1.43. What is the difference between the Electricity production(% of total) in Lower middle income in 2005 and the Electricity production(% of total) in Austria in 2007?
Provide a short and direct response. -7.98. What is the difference between the Electricity production(% of total) of Lower middle income in 2005 and the Electricity production(% of total) of Canada in 2007?
Your response must be concise. 0.16. What is the difference between the Electricity production(% of total) of Austria in 2005 and the Electricity production(% of total) of Canada in 2007?
Your answer should be very brief. 4.32. What is the difference between the Electricity production(% of total) in Austria in 2005 and the Electricity production(% of total) in Tunisia in 2007?
Keep it short and to the point. 5.83. What is the difference between the Electricity production(% of total) in Canada in 2005 and the Electricity production(% of total) in Tunisia in 2007?
Ensure brevity in your answer.  1.41. What is the difference between the Electricity production(% of total) of Lower middle income in 2006 and the Electricity production(% of total) of Austria in 2007?
Provide a short and direct response. -7.76. What is the difference between the Electricity production(% of total) in Lower middle income in 2006 and the Electricity production(% of total) in Canada in 2007?
Provide a short and direct response. 0.38. What is the difference between the Electricity production(% of total) of Lower middle income in 2006 and the Electricity production(% of total) of Tunisia in 2007?
Make the answer very short. 1.89. What is the difference between the Electricity production(% of total) in Austria in 2006 and the Electricity production(% of total) in Canada in 2007?
Your response must be concise. 6.48. What is the difference between the Electricity production(% of total) of Austria in 2006 and the Electricity production(% of total) of Tunisia in 2007?
Provide a succinct answer. 7.98. What is the difference between the Electricity production(% of total) of Canada in 2006 and the Electricity production(% of total) of Tunisia in 2007?
Your answer should be very brief. 1.52. What is the average Electricity production(% of total) of Lower middle income per year?
Keep it short and to the point. 1.93. What is the average Electricity production(% of total) of Austria per year?
Your answer should be compact. 5.15. What is the average Electricity production(% of total) in Canada per year?
Offer a very short reply. 1.65. What is the average Electricity production(% of total) in Tunisia per year?
Ensure brevity in your answer.  0.28. In the year 2000, what is the difference between the Electricity production(% of total) of Lower middle income and Electricity production(% of total) of Austria?
Provide a succinct answer. -0.96. In the year 2000, what is the difference between the Electricity production(% of total) in Lower middle income and Electricity production(% of total) in Canada?
Ensure brevity in your answer.  0.31. In the year 2000, what is the difference between the Electricity production(% of total) in Lower middle income and Electricity production(% of total) in Tunisia?
Make the answer very short. 1.49. In the year 2000, what is the difference between the Electricity production(% of total) in Austria and Electricity production(% of total) in Canada?
Make the answer very short. 1.27. In the year 2000, what is the difference between the Electricity production(% of total) in Austria and Electricity production(% of total) in Tunisia?
Make the answer very short. 2.45. In the year 2000, what is the difference between the Electricity production(% of total) of Canada and Electricity production(% of total) of Tunisia?
Keep it short and to the point. 1.18. In the year 2001, what is the difference between the Electricity production(% of total) in Lower middle income and Electricity production(% of total) in Austria?
Make the answer very short. -1.16. In the year 2001, what is the difference between the Electricity production(% of total) of Lower middle income and Electricity production(% of total) of Canada?
Make the answer very short. 0.24. In the year 2001, what is the difference between the Electricity production(% of total) in Lower middle income and Electricity production(% of total) in Tunisia?
Your response must be concise. 1.54. In the year 2001, what is the difference between the Electricity production(% of total) in Austria and Electricity production(% of total) in Canada?
Offer a terse response. 1.39. In the year 2001, what is the difference between the Electricity production(% of total) of Austria and Electricity production(% of total) of Tunisia?
Offer a very short reply. 2.7. In the year 2001, what is the difference between the Electricity production(% of total) of Canada and Electricity production(% of total) of Tunisia?
Ensure brevity in your answer.  1.31. In the year 2002, what is the difference between the Electricity production(% of total) of Lower middle income and Electricity production(% of total) of Austria?
Give a very brief answer. -0.98. In the year 2002, what is the difference between the Electricity production(% of total) of Lower middle income and Electricity production(% of total) of Canada?
Give a very brief answer. 0.19. In the year 2002, what is the difference between the Electricity production(% of total) of Lower middle income and Electricity production(% of total) of Tunisia?
Offer a very short reply. 1.51. In the year 2002, what is the difference between the Electricity production(% of total) in Austria and Electricity production(% of total) in Canada?
Provide a succinct answer. 1.17. In the year 2002, what is the difference between the Electricity production(% of total) of Austria and Electricity production(% of total) of Tunisia?
Your answer should be compact. 2.49. In the year 2002, what is the difference between the Electricity production(% of total) of Canada and Electricity production(% of total) of Tunisia?
Ensure brevity in your answer.  1.32. In the year 2003, what is the difference between the Electricity production(% of total) of Lower middle income and Electricity production(% of total) of Austria?
Provide a succinct answer. -1.79. In the year 2003, what is the difference between the Electricity production(% of total) in Lower middle income and Electricity production(% of total) in Canada?
Provide a succinct answer. 0.14. In the year 2003, what is the difference between the Electricity production(% of total) of Lower middle income and Electricity production(% of total) of Tunisia?
Your response must be concise. 1.53. In the year 2003, what is the difference between the Electricity production(% of total) in Austria and Electricity production(% of total) in Canada?
Ensure brevity in your answer.  1.94. In the year 2003, what is the difference between the Electricity production(% of total) in Austria and Electricity production(% of total) in Tunisia?
Ensure brevity in your answer.  3.32. In the year 2003, what is the difference between the Electricity production(% of total) of Canada and Electricity production(% of total) of Tunisia?
Your answer should be very brief. 1.38. In the year 2004, what is the difference between the Electricity production(% of total) of Lower middle income and Electricity production(% of total) of Austria?
Your response must be concise. -2.93. In the year 2004, what is the difference between the Electricity production(% of total) in Lower middle income and Electricity production(% of total) in Canada?
Offer a very short reply. 0.3. In the year 2004, what is the difference between the Electricity production(% of total) of Lower middle income and Electricity production(% of total) of Tunisia?
Your answer should be compact. 1.56. In the year 2004, what is the difference between the Electricity production(% of total) of Austria and Electricity production(% of total) of Canada?
Ensure brevity in your answer.  3.23. In the year 2004, what is the difference between the Electricity production(% of total) of Austria and Electricity production(% of total) of Tunisia?
Your response must be concise. 4.49. In the year 2004, what is the difference between the Electricity production(% of total) in Canada and Electricity production(% of total) in Tunisia?
Keep it short and to the point. 1.26. In the year 2005, what is the difference between the Electricity production(% of total) of Lower middle income and Electricity production(% of total) of Austria?
Make the answer very short. -4.16. In the year 2005, what is the difference between the Electricity production(% of total) of Lower middle income and Electricity production(% of total) of Canada?
Your response must be concise. 0.26. In the year 2005, what is the difference between the Electricity production(% of total) of Lower middle income and Electricity production(% of total) of Tunisia?
Offer a terse response. 1.65. In the year 2005, what is the difference between the Electricity production(% of total) of Austria and Electricity production(% of total) of Canada?
Provide a short and direct response. 4.42. In the year 2005, what is the difference between the Electricity production(% of total) of Austria and Electricity production(% of total) of Tunisia?
Keep it short and to the point. 5.81. In the year 2005, what is the difference between the Electricity production(% of total) of Canada and Electricity production(% of total) of Tunisia?
Keep it short and to the point. 1.39. In the year 2006, what is the difference between the Electricity production(% of total) of Lower middle income and Electricity production(% of total) of Austria?
Offer a very short reply. -6.09. In the year 2006, what is the difference between the Electricity production(% of total) of Lower middle income and Electricity production(% of total) of Canada?
Offer a terse response. 0.36. In the year 2006, what is the difference between the Electricity production(% of total) of Lower middle income and Electricity production(% of total) of Tunisia?
Offer a terse response. 1.91. In the year 2006, what is the difference between the Electricity production(% of total) of Austria and Electricity production(% of total) of Canada?
Give a very brief answer. 6.46. In the year 2006, what is the difference between the Electricity production(% of total) of Austria and Electricity production(% of total) of Tunisia?
Ensure brevity in your answer.  8. In the year 2006, what is the difference between the Electricity production(% of total) in Canada and Electricity production(% of total) in Tunisia?
Make the answer very short. 1.54. In the year 2007, what is the difference between the Electricity production(% of total) of Lower middle income and Electricity production(% of total) of Austria?
Your response must be concise. -7.63. In the year 2007, what is the difference between the Electricity production(% of total) in Lower middle income and Electricity production(% of total) in Canada?
Make the answer very short. 0.51. In the year 2007, what is the difference between the Electricity production(% of total) in Lower middle income and Electricity production(% of total) in Tunisia?
Make the answer very short. 2.01. In the year 2007, what is the difference between the Electricity production(% of total) in Austria and Electricity production(% of total) in Canada?
Provide a succinct answer. 8.14. In the year 2007, what is the difference between the Electricity production(% of total) in Austria and Electricity production(% of total) in Tunisia?
Give a very brief answer. 9.64. In the year 2007, what is the difference between the Electricity production(% of total) of Canada and Electricity production(% of total) of Tunisia?
Keep it short and to the point. 1.5. What is the ratio of the Electricity production(% of total) in Lower middle income in 2000 to that in 2001?
Provide a short and direct response. 0.97. What is the ratio of the Electricity production(% of total) in Austria in 2000 to that in 2001?
Give a very brief answer. 0.92. What is the ratio of the Electricity production(% of total) in Canada in 2000 to that in 2001?
Your response must be concise. 0.92. What is the ratio of the Electricity production(% of total) of Tunisia in 2000 to that in 2001?
Provide a succinct answer. 1.03. What is the ratio of the Electricity production(% of total) in Lower middle income in 2000 to that in 2002?
Provide a succinct answer. 0.97. What is the ratio of the Electricity production(% of total) in Austria in 2000 to that in 2002?
Offer a terse response. 0.97. What is the ratio of the Electricity production(% of total) in Canada in 2000 to that in 2002?
Make the answer very short. 0.89. What is the ratio of the Electricity production(% of total) of Tunisia in 2000 to that in 2002?
Offer a very short reply. 0.86. What is the ratio of the Electricity production(% of total) of Lower middle income in 2000 to that in 2003?
Keep it short and to the point. 0.94. What is the ratio of the Electricity production(% of total) in Austria in 2000 to that in 2003?
Provide a short and direct response. 0.74. What is the ratio of the Electricity production(% of total) in Canada in 2000 to that in 2003?
Offer a terse response. 0.84. What is the ratio of the Electricity production(% of total) of Tunisia in 2000 to that in 2003?
Provide a short and direct response. 0.74. What is the ratio of the Electricity production(% of total) of Lower middle income in 2000 to that in 2004?
Offer a very short reply. 0.89. What is the ratio of the Electricity production(% of total) of Austria in 2000 to that in 2004?
Provide a short and direct response. 0.55. What is the ratio of the Electricity production(% of total) of Canada in 2000 to that in 2004?
Keep it short and to the point. 0.86. What is the ratio of the Electricity production(% of total) in Tunisia in 2000 to that in 2004?
Offer a very short reply. 0.59. What is the ratio of the Electricity production(% of total) of Lower middle income in 2000 to that in 2005?
Your answer should be very brief. 0.86. What is the ratio of the Electricity production(% of total) in Austria in 2000 to that in 2005?
Your answer should be compact. 0.43. What is the ratio of the Electricity production(% of total) of Canada in 2000 to that in 2005?
Provide a succinct answer. 0.81. What is the ratio of the Electricity production(% of total) in Tunisia in 2000 to that in 2005?
Keep it short and to the point. 0.65. What is the ratio of the Electricity production(% of total) of Lower middle income in 2000 to that in 2006?
Offer a very short reply. 0.78. What is the ratio of the Electricity production(% of total) in Austria in 2000 to that in 2006?
Provide a succinct answer. 0.32. What is the ratio of the Electricity production(% of total) of Canada in 2000 to that in 2006?
Make the answer very short. 0.76. What is the ratio of the Electricity production(% of total) in Tunisia in 2000 to that in 2006?
Give a very brief answer. 0.75. What is the ratio of the Electricity production(% of total) in Lower middle income in 2000 to that in 2007?
Offer a terse response. 0.73. What is the ratio of the Electricity production(% of total) in Austria in 2000 to that in 2007?
Make the answer very short. 0.27. What is the ratio of the Electricity production(% of total) in Canada in 2000 to that in 2007?
Provide a succinct answer. 0.77. What is the ratio of the Electricity production(% of total) of Tunisia in 2000 to that in 2007?
Provide a short and direct response. 0.69. What is the ratio of the Electricity production(% of total) in Lower middle income in 2001 to that in 2002?
Offer a very short reply. 0.99. What is the ratio of the Electricity production(% of total) of Austria in 2001 to that in 2002?
Your answer should be very brief. 1.06. What is the ratio of the Electricity production(% of total) in Canada in 2001 to that in 2002?
Give a very brief answer. 0.96. What is the ratio of the Electricity production(% of total) in Tunisia in 2001 to that in 2002?
Provide a short and direct response. 0.83. What is the ratio of the Electricity production(% of total) in Lower middle income in 2001 to that in 2003?
Offer a very short reply. 0.96. What is the ratio of the Electricity production(% of total) in Austria in 2001 to that in 2003?
Make the answer very short. 0.81. What is the ratio of the Electricity production(% of total) of Canada in 2001 to that in 2003?
Your response must be concise. 0.9. What is the ratio of the Electricity production(% of total) in Tunisia in 2001 to that in 2003?
Offer a very short reply. 0.72. What is the ratio of the Electricity production(% of total) of Lower middle income in 2001 to that in 2004?
Your answer should be very brief. 0.91. What is the ratio of the Electricity production(% of total) in Austria in 2001 to that in 2004?
Make the answer very short. 0.6. What is the ratio of the Electricity production(% of total) in Canada in 2001 to that in 2004?
Offer a very short reply. 0.93. What is the ratio of the Electricity production(% of total) of Tunisia in 2001 to that in 2004?
Give a very brief answer. 0.57. What is the ratio of the Electricity production(% of total) of Lower middle income in 2001 to that in 2005?
Offer a very short reply. 0.89. What is the ratio of the Electricity production(% of total) in Austria in 2001 to that in 2005?
Your response must be concise. 0.47. What is the ratio of the Electricity production(% of total) of Canada in 2001 to that in 2005?
Ensure brevity in your answer.  0.88. What is the ratio of the Electricity production(% of total) of Tunisia in 2001 to that in 2005?
Give a very brief answer. 0.64. What is the ratio of the Electricity production(% of total) of Lower middle income in 2001 to that in 2006?
Your answer should be very brief. 0.8. What is the ratio of the Electricity production(% of total) of Austria in 2001 to that in 2006?
Your response must be concise. 0.35. What is the ratio of the Electricity production(% of total) of Canada in 2001 to that in 2006?
Make the answer very short. 0.83. What is the ratio of the Electricity production(% of total) of Tunisia in 2001 to that in 2006?
Offer a very short reply. 0.72. What is the ratio of the Electricity production(% of total) of Lower middle income in 2001 to that in 2007?
Your response must be concise. 0.75. What is the ratio of the Electricity production(% of total) of Austria in 2001 to that in 2007?
Offer a terse response. 0.29. What is the ratio of the Electricity production(% of total) of Canada in 2001 to that in 2007?
Offer a terse response. 0.83. What is the ratio of the Electricity production(% of total) in Tunisia in 2001 to that in 2007?
Your response must be concise. 0.67. What is the ratio of the Electricity production(% of total) in Lower middle income in 2002 to that in 2003?
Your answer should be compact. 0.97. What is the ratio of the Electricity production(% of total) in Austria in 2002 to that in 2003?
Offer a very short reply. 0.76. What is the ratio of the Electricity production(% of total) in Canada in 2002 to that in 2003?
Offer a very short reply. 0.94. What is the ratio of the Electricity production(% of total) in Tunisia in 2002 to that in 2003?
Offer a terse response. 0.87. What is the ratio of the Electricity production(% of total) in Lower middle income in 2002 to that in 2004?
Provide a succinct answer. 0.92. What is the ratio of the Electricity production(% of total) in Austria in 2002 to that in 2004?
Provide a short and direct response. 0.57. What is the ratio of the Electricity production(% of total) in Canada in 2002 to that in 2004?
Your answer should be compact. 0.97. What is the ratio of the Electricity production(% of total) in Tunisia in 2002 to that in 2004?
Keep it short and to the point. 0.69. What is the ratio of the Electricity production(% of total) of Lower middle income in 2002 to that in 2005?
Offer a very short reply. 0.89. What is the ratio of the Electricity production(% of total) in Austria in 2002 to that in 2005?
Your answer should be very brief. 0.45. What is the ratio of the Electricity production(% of total) of Canada in 2002 to that in 2005?
Ensure brevity in your answer.  0.91. What is the ratio of the Electricity production(% of total) in Tunisia in 2002 to that in 2005?
Provide a succinct answer. 0.76. What is the ratio of the Electricity production(% of total) of Lower middle income in 2002 to that in 2006?
Give a very brief answer. 0.8. What is the ratio of the Electricity production(% of total) of Austria in 2002 to that in 2006?
Your answer should be compact. 0.33. What is the ratio of the Electricity production(% of total) in Canada in 2002 to that in 2006?
Your answer should be very brief. 0.86. What is the ratio of the Electricity production(% of total) in Tunisia in 2002 to that in 2006?
Offer a very short reply. 0.87. What is the ratio of the Electricity production(% of total) of Lower middle income in 2002 to that in 2007?
Provide a succinct answer. 0.76. What is the ratio of the Electricity production(% of total) of Austria in 2002 to that in 2007?
Offer a terse response. 0.28. What is the ratio of the Electricity production(% of total) in Canada in 2002 to that in 2007?
Provide a succinct answer. 0.87. What is the ratio of the Electricity production(% of total) of Tunisia in 2002 to that in 2007?
Your response must be concise. 0.81. What is the ratio of the Electricity production(% of total) in Lower middle income in 2003 to that in 2004?
Give a very brief answer. 0.94. What is the ratio of the Electricity production(% of total) of Austria in 2003 to that in 2004?
Your response must be concise. 0.74. What is the ratio of the Electricity production(% of total) of Canada in 2003 to that in 2004?
Provide a succinct answer. 1.03. What is the ratio of the Electricity production(% of total) in Tunisia in 2003 to that in 2004?
Provide a short and direct response. 0.79. What is the ratio of the Electricity production(% of total) in Lower middle income in 2003 to that in 2005?
Your answer should be very brief. 0.92. What is the ratio of the Electricity production(% of total) of Austria in 2003 to that in 2005?
Keep it short and to the point. 0.59. What is the ratio of the Electricity production(% of total) of Canada in 2003 to that in 2005?
Your answer should be very brief. 0.97. What is the ratio of the Electricity production(% of total) in Tunisia in 2003 to that in 2005?
Offer a terse response. 0.88. What is the ratio of the Electricity production(% of total) of Lower middle income in 2003 to that in 2006?
Your answer should be very brief. 0.83. What is the ratio of the Electricity production(% of total) in Austria in 2003 to that in 2006?
Make the answer very short. 0.44. What is the ratio of the Electricity production(% of total) in Canada in 2003 to that in 2006?
Your answer should be compact. 0.91. What is the ratio of the Electricity production(% of total) in Tunisia in 2003 to that in 2006?
Provide a short and direct response. 1. What is the ratio of the Electricity production(% of total) of Lower middle income in 2003 to that in 2007?
Your response must be concise. 0.78. What is the ratio of the Electricity production(% of total) in Austria in 2003 to that in 2007?
Make the answer very short. 0.36. What is the ratio of the Electricity production(% of total) in Canada in 2003 to that in 2007?
Your answer should be very brief. 0.92. What is the ratio of the Electricity production(% of total) in Tunisia in 2003 to that in 2007?
Provide a succinct answer. 0.93. What is the ratio of the Electricity production(% of total) in Lower middle income in 2004 to that in 2005?
Offer a very short reply. 0.97. What is the ratio of the Electricity production(% of total) in Austria in 2004 to that in 2005?
Offer a very short reply. 0.79. What is the ratio of the Electricity production(% of total) of Canada in 2004 to that in 2005?
Offer a very short reply. 0.95. What is the ratio of the Electricity production(% of total) of Tunisia in 2004 to that in 2005?
Provide a short and direct response. 1.11. What is the ratio of the Electricity production(% of total) of Lower middle income in 2004 to that in 2006?
Your response must be concise. 0.88. What is the ratio of the Electricity production(% of total) of Austria in 2004 to that in 2006?
Your answer should be very brief. 0.59. What is the ratio of the Electricity production(% of total) in Canada in 2004 to that in 2006?
Provide a succinct answer. 0.89. What is the ratio of the Electricity production(% of total) of Tunisia in 2004 to that in 2006?
Your answer should be compact. 1.27. What is the ratio of the Electricity production(% of total) of Lower middle income in 2004 to that in 2007?
Offer a very short reply. 0.83. What is the ratio of the Electricity production(% of total) of Austria in 2004 to that in 2007?
Provide a succinct answer. 0.49. What is the ratio of the Electricity production(% of total) of Canada in 2004 to that in 2007?
Offer a terse response. 0.9. What is the ratio of the Electricity production(% of total) in Tunisia in 2004 to that in 2007?
Provide a short and direct response. 1.18. What is the ratio of the Electricity production(% of total) of Lower middle income in 2005 to that in 2006?
Your answer should be very brief. 0.9. What is the ratio of the Electricity production(% of total) of Austria in 2005 to that in 2006?
Your response must be concise. 0.74. What is the ratio of the Electricity production(% of total) in Canada in 2005 to that in 2006?
Offer a terse response. 0.94. What is the ratio of the Electricity production(% of total) of Tunisia in 2005 to that in 2006?
Your response must be concise. 1.14. What is the ratio of the Electricity production(% of total) in Lower middle income in 2005 to that in 2007?
Ensure brevity in your answer.  0.85. What is the ratio of the Electricity production(% of total) of Austria in 2005 to that in 2007?
Offer a very short reply. 0.62. What is the ratio of the Electricity production(% of total) in Canada in 2005 to that in 2007?
Your answer should be very brief. 0.95. What is the ratio of the Electricity production(% of total) in Tunisia in 2005 to that in 2007?
Provide a short and direct response. 1.06. What is the ratio of the Electricity production(% of total) of Lower middle income in 2006 to that in 2007?
Keep it short and to the point. 0.94. What is the ratio of the Electricity production(% of total) of Austria in 2006 to that in 2007?
Provide a succinct answer. 0.83. What is the ratio of the Electricity production(% of total) of Canada in 2006 to that in 2007?
Your answer should be compact. 1.01. What is the ratio of the Electricity production(% of total) of Tunisia in 2006 to that in 2007?
Offer a terse response. 0.93. What is the difference between the highest and the second highest Electricity production(% of total) in Lower middle income?
Offer a terse response. 0.13. What is the difference between the highest and the second highest Electricity production(% of total) of Austria?
Give a very brief answer. 1.66. What is the difference between the highest and the second highest Electricity production(% of total) in Canada?
Your answer should be very brief. 0.02. What is the difference between the highest and the second highest Electricity production(% of total) in Tunisia?
Offer a terse response. 0.04. What is the difference between the highest and the lowest Electricity production(% of total) of Lower middle income?
Offer a very short reply. 0.62. What is the difference between the highest and the lowest Electricity production(% of total) in Austria?
Provide a short and direct response. 7.29. What is the difference between the highest and the lowest Electricity production(% of total) in Canada?
Make the answer very short. 0.43. What is the difference between the highest and the lowest Electricity production(% of total) in Tunisia?
Give a very brief answer. 0.16. 